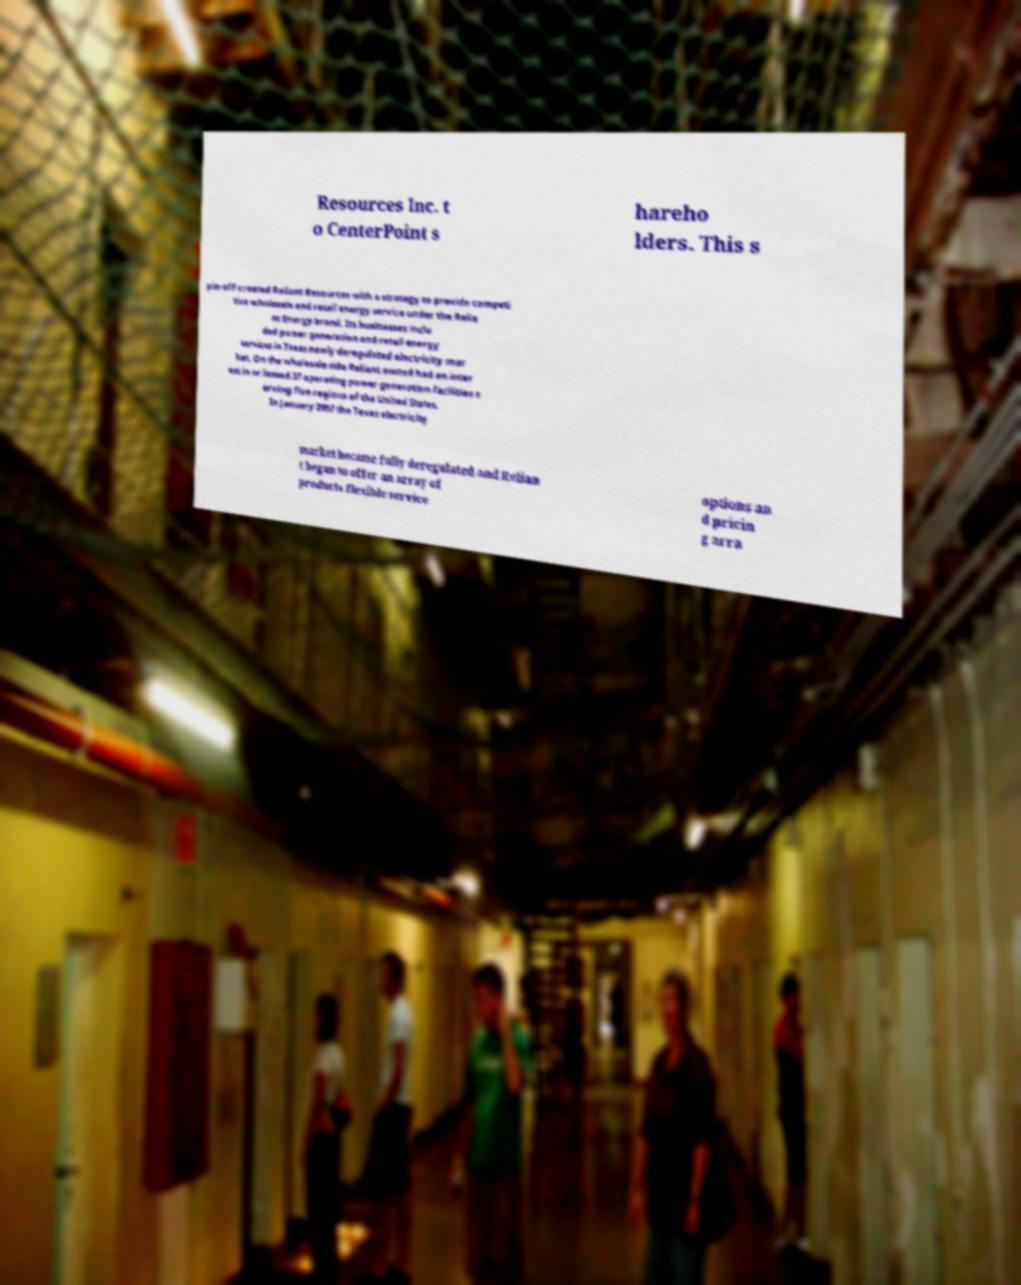Could you assist in decoding the text presented in this image and type it out clearly? Resources Inc. t o CenterPoint s hareho lders. This s pin-off created Reliant Resources with a strategy to provide competi tive wholesale and retail energy service under the Relia nt Energy brand. Its businesses inclu ded power generation and retail energy services in Texas newly deregulated electricity mar ket. On the wholesale side Reliant owned had an inter est in or leased 37 operating power generation facilities s erving five regions of the United States. In January 2007 the Texas electricity market became fully deregulated and Relian t began to offer an array of products flexible service options an d pricin g arra 